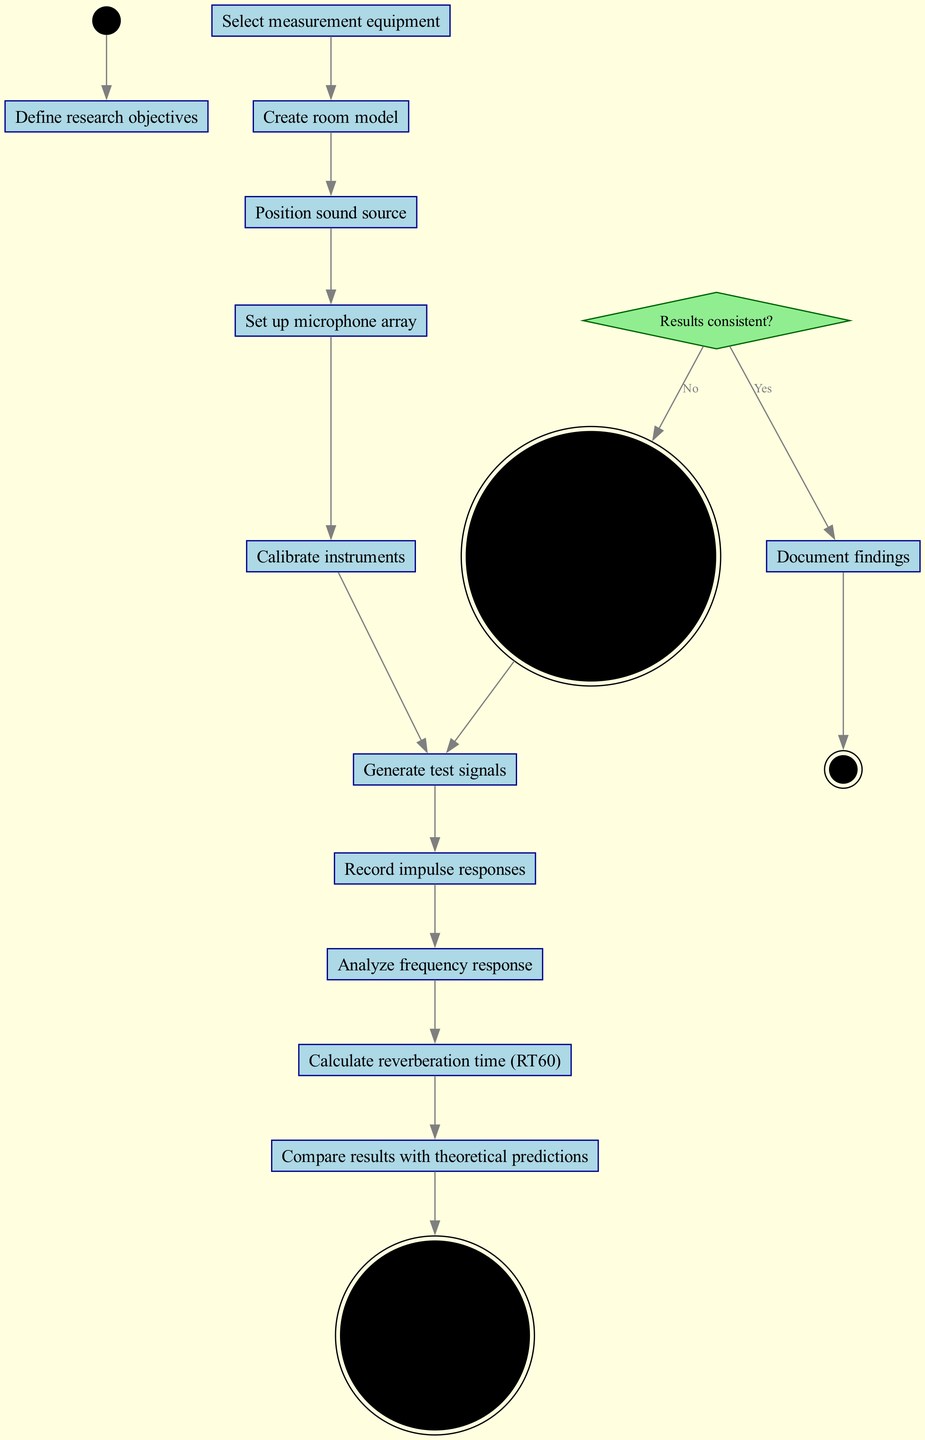What is the first activity in the diagram? The first activity is represented directly after the 'Start' node in the flow. Checking the initial connection leads to 'Define research objectives' as the first activity in the sequence.
Answer: Define research objectives How many activities are there in total? The total number of activities is simply the count of listed activities in the diagram. There are 12 activities listed before the decision node.
Answer: 12 What happens after calibrating instruments? Following 'Calibrate instruments', the diagram shows a direct edge to 'Generate test signals'. This is the next step in the sequence.
Answer: Generate test signals What is the decision question in the diagram? Decision nodes contain questions that determine the flow of the diagram. Here, the question posed is "Results consistent?" which can lead to further actions based on the answer.
Answer: Results consistent? What is the final node in the activity diagram? The final node is reached after all activities and decisions are completed. In this flow, the diagram ends with 'End', indicating the process completion.
Answer: End If the results are not consistent, what is the next step? When the decision is "No" for the question "Results consistent?", the diagram indicates to 'Adjust experimental setup', which reflects the required action to address inconsistency.
Answer: Adjust experimental setup Which activity follows analyzing frequency response? From the flow, the activity that follows 'Analyze frequency response' is 'Calculate reverberation time (RT60)'. This transition is directly shown with an edge connecting both activities.
Answer: Calculate reverberation time (RT60) How does one proceed from comparing results? After 'Compare results with theoretical predictions', the next step involves evaluating whether the results are consistent, as indicated by the decision node that follows this activity.
Answer: Results consistent? What is the sequence of activities starting from positioning the sound source? The sequence begins with 'Position sound source', followed by 'Set up microphone array', then 'Calibrate instruments', 'Generate test signals', 'Record impulse responses', 'Analyze frequency response', and 'Calculate reverberation time (RT60)'. This outlined flow must be strictly followed.
Answer: Set up microphone array, Calibrate instruments, Generate test signals, Record impulse responses, Analyze frequency response, Calculate reverberation time (RT60) 